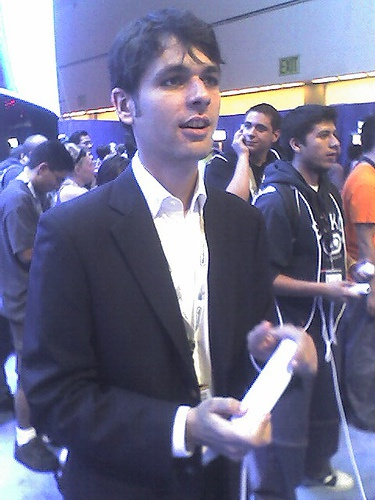Describe the objects in this image and their specific colors. I can see people in white, black, purple, and gray tones, people in white, black, purple, and gray tones, people in white, purple, blue, and navy tones, people in white, purple, salmon, navy, and brown tones, and people in white, purple, lavender, navy, and lightpink tones in this image. 